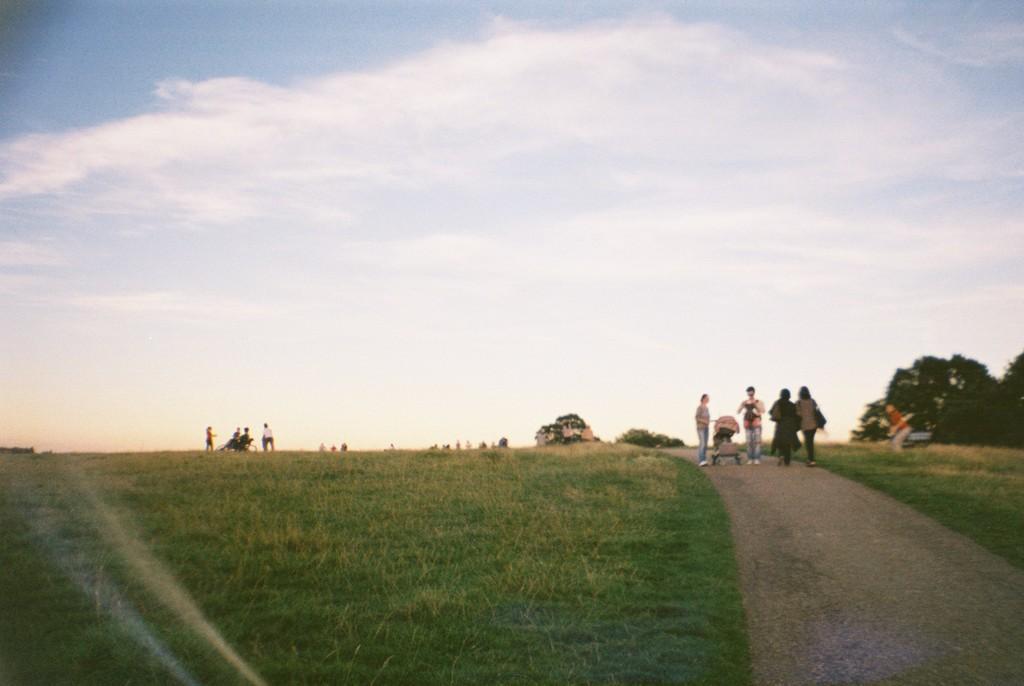In one or two sentences, can you explain what this image depicts? In this image we can see a grassy land. There are many people in the image. There is the sky in the image. There is a road in the image. There are many trees in the image. There is a house in the image. 